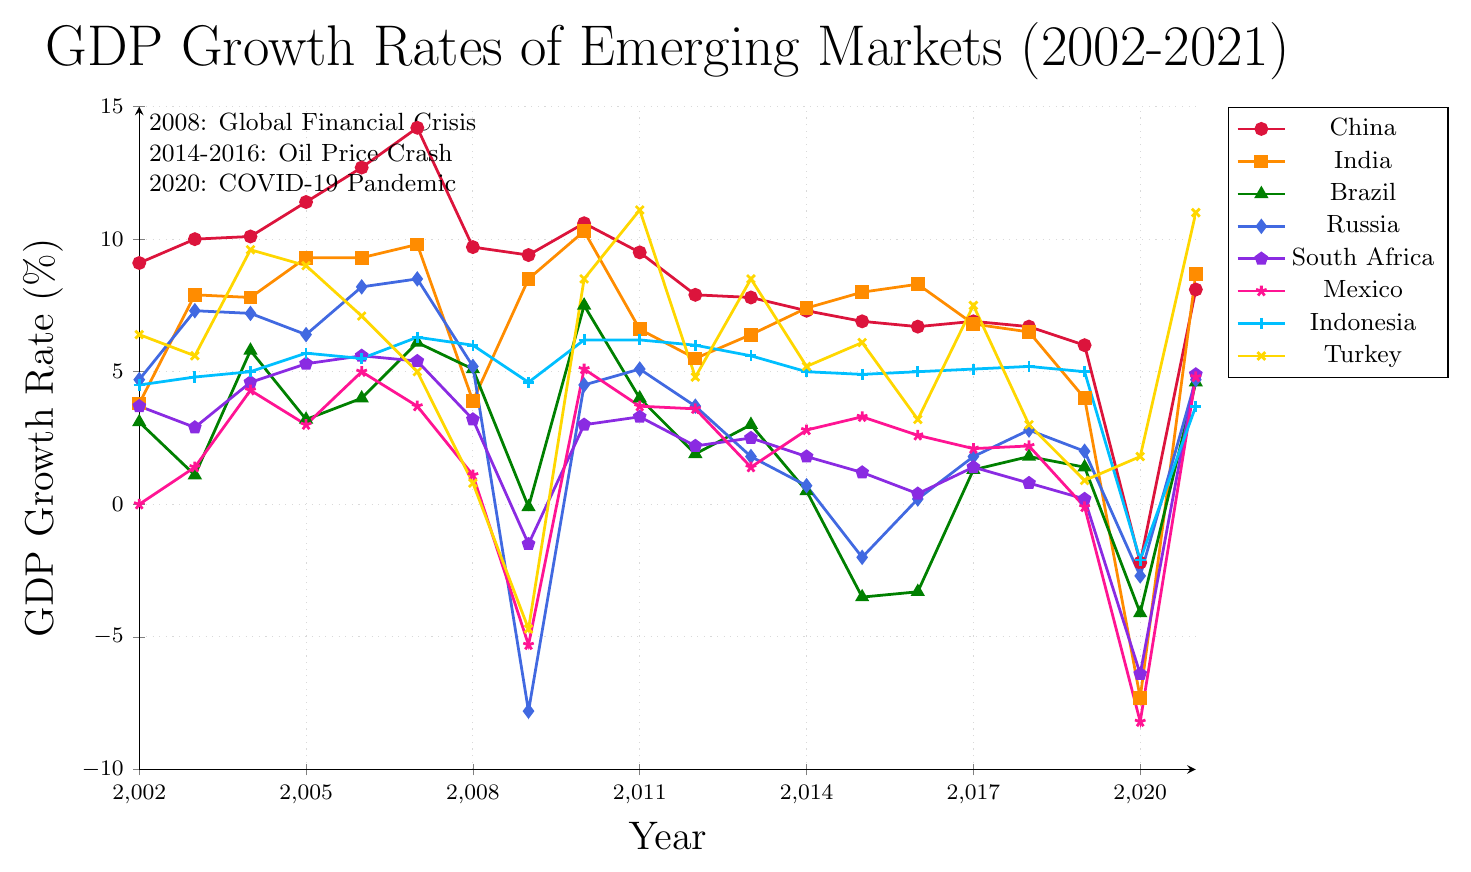What was the GDP growth rate of China in 2020? Looking at the red line marked with circles corresponding to China, in 2020, it falls at the point labeled -2.2 on the vertical axis.
Answer: -2.2% Which country had the highest GDP growth rate in 2010? Observing the values for the year 2010 across all lines, the highest point is the blue square line representing India at a rate of 10.3%.
Answer: India How did Brazil's GDP growth rate change between 2009 and 2015? Brazil's GDP growth rate in 2009 was -0.1%, and in 2015 it was -3.5%. The change can be calculated as -3.5% - (-0.1%) = -3.4%.
Answer: -3.4% During the 2014-2016 oil price crash, which country's GDP growth rate saw the steepest decline and by how much? From 2014 to 2016, Russia's GDP growth rate declined from 0.7% to 0.2%, a difference of 0.5 percentage points. However, Brazil's declined from 0.5% to -3.3%, a difference of 3.8 percentage points, which is steeper.
Answer: Brazil, -3.8% What year did South Africa experience its lowest GDP growth rate during the period and what was the rate? Observing the purple pentagon line for South Africa, the lowest point is in 2020 at -6.4%.
Answer: 2020, -6.4% Compare the GDP growth rates of Mexico and Turkey in 2009. Which was higher and by how much? Mexico's GDP growth rate in 2009 was -5.3%, and Turkey’s was -4.7%. Turkey's rate was higher by -4.7% - (-5.3%) = 0.6%.
Answer: Turkey, 0.6% What is the average GDP growth rate of Indonesia from 2010 to 2012? Indonesia's GDP growth rates from 2010 to 2012 are 6.2%, 6.2%, 6.0%. Average rate = (6.2 + 6.2 + 6.0) / 3 = 6.13%.
Answer: 6.13% How did the GDP growth rate of Russia change from 2008 to 2009 during the global financial crisis? Russia's GDP growth rate dropped from 5.2% in 2008 to -7.8% in 2009. The change is -7.8% - 5.2% = -13%.
Answer: -13% Which country had a positive GDP growth rate in 2020, and what was it? Observing all the lines in 2020, only Turkey, represented by the yellow crosses, has a positive GDP growth rate of 1.8%.
Answer: Turkey, 1.8% What is the difference in GDP growth rates between India and China in 2021? India's GDP growth rate in 2021 is 8.7% and China's is 8.1%. The difference is 8.7% - 8.1% = 0.6%.
Answer: 0.6% 